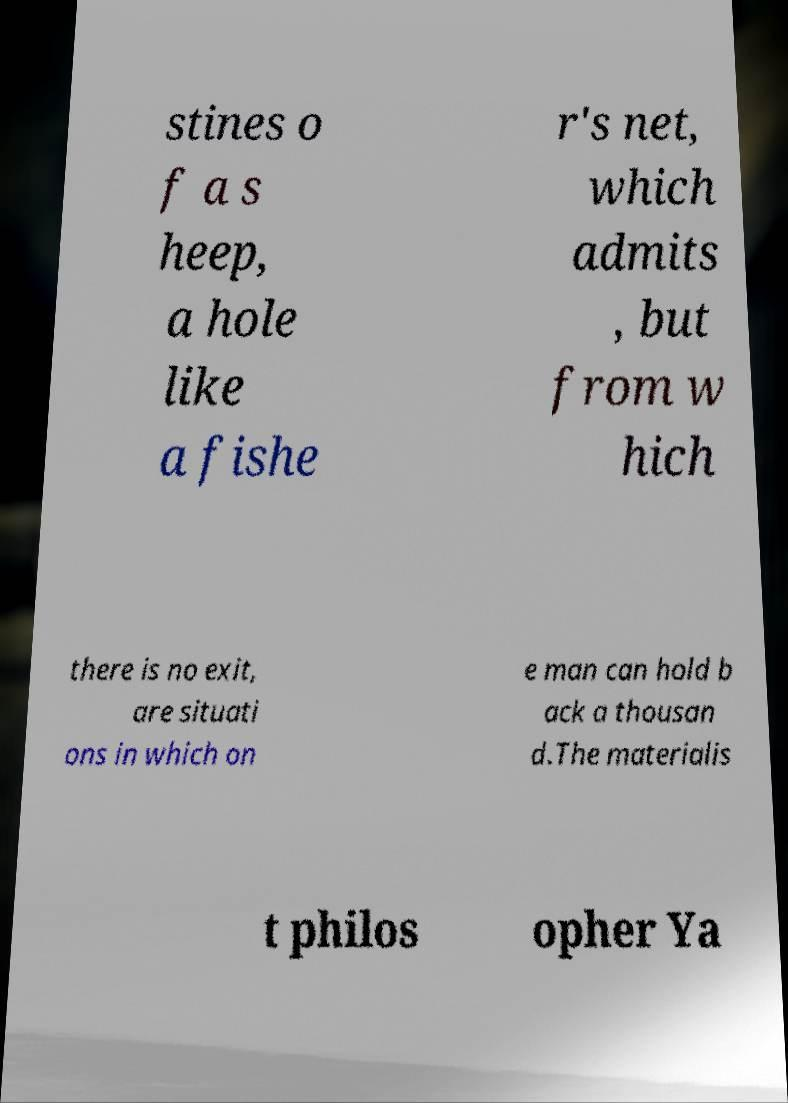Can you read and provide the text displayed in the image?This photo seems to have some interesting text. Can you extract and type it out for me? stines o f a s heep, a hole like a fishe r's net, which admits , but from w hich there is no exit, are situati ons in which on e man can hold b ack a thousan d.The materialis t philos opher Ya 